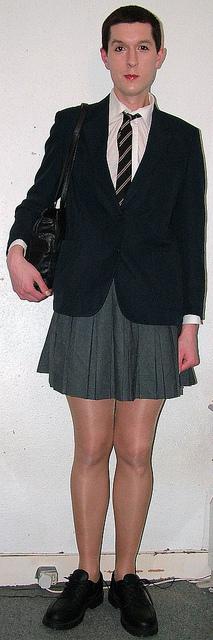Does this person wear makeup?
Keep it brief. Yes. Guy or girl?
Write a very short answer. Guy. What is the person wearing on their bottom half?
Give a very brief answer. Skirt. 